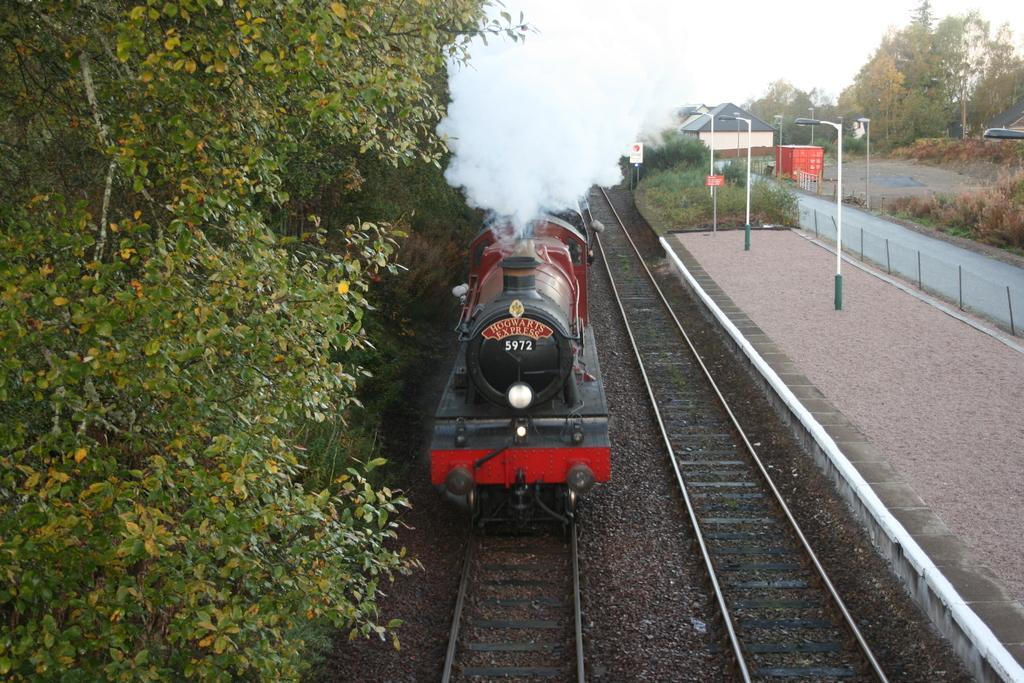How would you summarize this image in a sentence or two? In this image there is a train on the railway tracks , and at the background there are railway tracks, trees, platform , boards, lights, poles, building, grass,sky. 